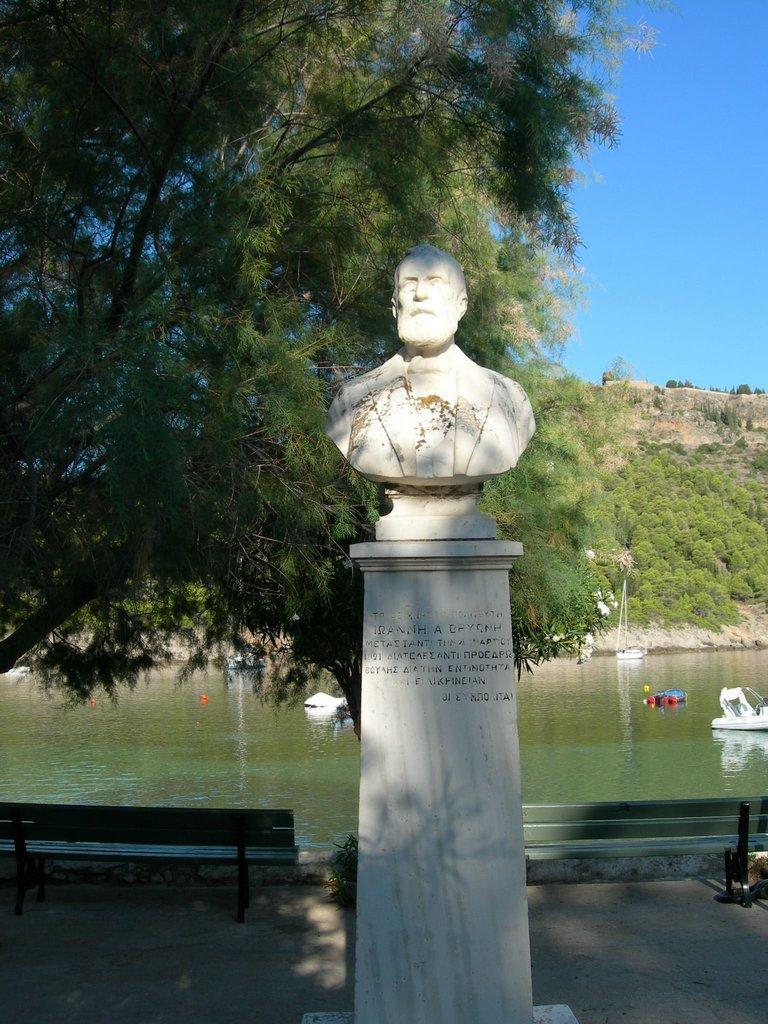In one or two sentences, can you explain what this image depicts? In this picture there is a statue. There is a tree There is a bench. There is a boat and water. The sky is blue. 